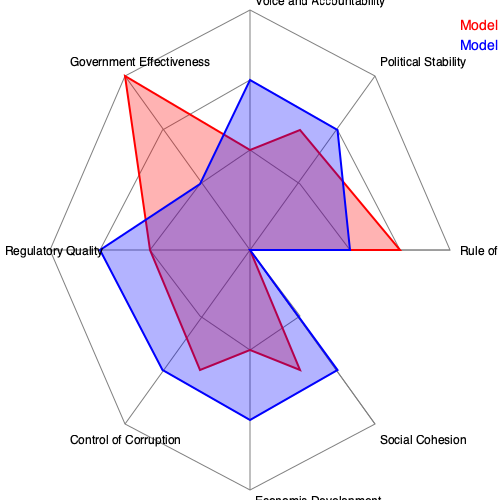Based on the radar chart comparing two governance models (A and B) in post-conflict societies, which model appears to be more effective in promoting overall good governance and why? Consider the strengths and weaknesses of each model across the various dimensions presented. To answer this question, we need to analyze the performance of both models across the eight dimensions presented in the radar chart:

1. Rule of Law: Both models perform equally well.

2. Political Stability: Model B outperforms Model A significantly.

3. Voice and Accountability: Model B shows better performance.

4. Government Effectiveness: Model A has a clear advantage.

5. Regulatory Quality: Model A significantly outperforms Model B.

6. Control of Corruption: Model B shows better performance.

7. Economic Development: Model B has a slight advantage.

8. Social Cohesion: Both models perform equally well.

Step-by-step analysis:

1. Count the dimensions where each model excels:
   Model A: 2 (Government Effectiveness, Regulatory Quality)
   Model B: 4 (Political Stability, Voice and Accountability, Control of Corruption, Economic Development)
   Equal: 2 (Rule of Law, Social Cohesion)

2. Assess the magnitude of differences:
   Model B's advantages in Political Stability and Voice and Accountability are substantial.
   Model A's advantage in Regulatory Quality is significant, but less so in Government Effectiveness.

3. Consider the interconnectedness of dimensions:
   Political Stability, Voice and Accountability, and Control of Corruption are closely related and mutually reinforcing.
   These factors can positively influence Economic Development and Social Cohesion.

4. Evaluate long-term implications:
   Model B's strengths in fundamental aspects of governance (Political Stability, Voice and Accountability, Control of Corruption) suggest better potential for sustainable development and conflict prevention.

5. Acknowledge trade-offs:
   Model A's stronger Regulatory Quality and Government Effectiveness could lead to more efficient policy implementation in the short term.
   However, Model B's advantages in foundational aspects of governance may lead to more stable and inclusive long-term outcomes.

Conclusion: Model B appears to be more effective in promoting overall good governance in post-conflict societies. Its strengths in critical areas such as Political Stability, Voice and Accountability, and Control of Corruption provide a solid foundation for sustainable development and conflict prevention. While Model A shows advantages in Regulatory Quality and Government Effectiveness, these may not be as impactful without the underlying stability and accountability that Model B offers.
Answer: Model B; better performance in fundamental governance aspects (Political Stability, Voice and Accountability, Control of Corruption) conducive to long-term stability and development in post-conflict societies. 